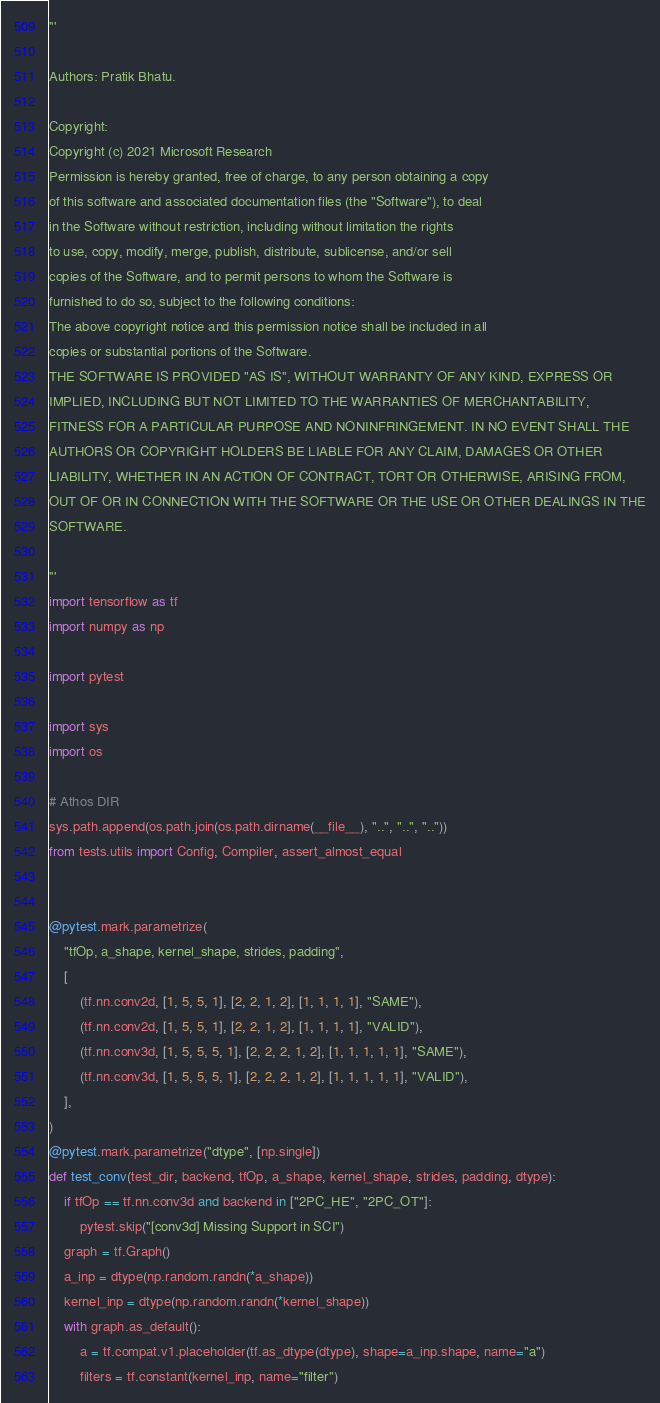Convert code to text. <code><loc_0><loc_0><loc_500><loc_500><_Python_>'''

Authors: Pratik Bhatu.

Copyright:
Copyright (c) 2021 Microsoft Research
Permission is hereby granted, free of charge, to any person obtaining a copy
of this software and associated documentation files (the "Software"), to deal
in the Software without restriction, including without limitation the rights
to use, copy, modify, merge, publish, distribute, sublicense, and/or sell
copies of the Software, and to permit persons to whom the Software is
furnished to do so, subject to the following conditions:
The above copyright notice and this permission notice shall be included in all
copies or substantial portions of the Software.
THE SOFTWARE IS PROVIDED "AS IS", WITHOUT WARRANTY OF ANY KIND, EXPRESS OR
IMPLIED, INCLUDING BUT NOT LIMITED TO THE WARRANTIES OF MERCHANTABILITY,
FITNESS FOR A PARTICULAR PURPOSE AND NONINFRINGEMENT. IN NO EVENT SHALL THE
AUTHORS OR COPYRIGHT HOLDERS BE LIABLE FOR ANY CLAIM, DAMAGES OR OTHER
LIABILITY, WHETHER IN AN ACTION OF CONTRACT, TORT OR OTHERWISE, ARISING FROM,
OUT OF OR IN CONNECTION WITH THE SOFTWARE OR THE USE OR OTHER DEALINGS IN THE
SOFTWARE.

'''
import tensorflow as tf
import numpy as np

import pytest

import sys
import os

# Athos DIR
sys.path.append(os.path.join(os.path.dirname(__file__), "..", "..", ".."))
from tests.utils import Config, Compiler, assert_almost_equal


@pytest.mark.parametrize(
    "tfOp, a_shape, kernel_shape, strides, padding",
    [
        (tf.nn.conv2d, [1, 5, 5, 1], [2, 2, 1, 2], [1, 1, 1, 1], "SAME"),
        (tf.nn.conv2d, [1, 5, 5, 1], [2, 2, 1, 2], [1, 1, 1, 1], "VALID"),
        (tf.nn.conv3d, [1, 5, 5, 5, 1], [2, 2, 2, 1, 2], [1, 1, 1, 1, 1], "SAME"),
        (tf.nn.conv3d, [1, 5, 5, 5, 1], [2, 2, 2, 1, 2], [1, 1, 1, 1, 1], "VALID"),
    ],
)
@pytest.mark.parametrize("dtype", [np.single])
def test_conv(test_dir, backend, tfOp, a_shape, kernel_shape, strides, padding, dtype):
    if tfOp == tf.nn.conv3d and backend in ["2PC_HE", "2PC_OT"]:
        pytest.skip("[conv3d] Missing Support in SCI")
    graph = tf.Graph()
    a_inp = dtype(np.random.randn(*a_shape))
    kernel_inp = dtype(np.random.randn(*kernel_shape))
    with graph.as_default():
        a = tf.compat.v1.placeholder(tf.as_dtype(dtype), shape=a_inp.shape, name="a")
        filters = tf.constant(kernel_inp, name="filter")</code> 